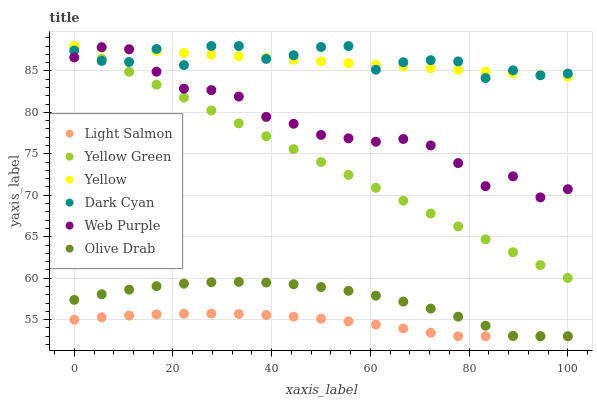Does Light Salmon have the minimum area under the curve?
Answer yes or no. Yes. Does Dark Cyan have the maximum area under the curve?
Answer yes or no. Yes. Does Yellow Green have the minimum area under the curve?
Answer yes or no. No. Does Yellow Green have the maximum area under the curve?
Answer yes or no. No. Is Yellow Green the smoothest?
Answer yes or no. Yes. Is Dark Cyan the roughest?
Answer yes or no. Yes. Is Yellow the smoothest?
Answer yes or no. No. Is Yellow the roughest?
Answer yes or no. No. Does Light Salmon have the lowest value?
Answer yes or no. Yes. Does Yellow Green have the lowest value?
Answer yes or no. No. Does Dark Cyan have the highest value?
Answer yes or no. Yes. Does Web Purple have the highest value?
Answer yes or no. No. Is Olive Drab less than Dark Cyan?
Answer yes or no. Yes. Is Yellow greater than Light Salmon?
Answer yes or no. Yes. Does Yellow intersect Dark Cyan?
Answer yes or no. Yes. Is Yellow less than Dark Cyan?
Answer yes or no. No. Is Yellow greater than Dark Cyan?
Answer yes or no. No. Does Olive Drab intersect Dark Cyan?
Answer yes or no. No. 